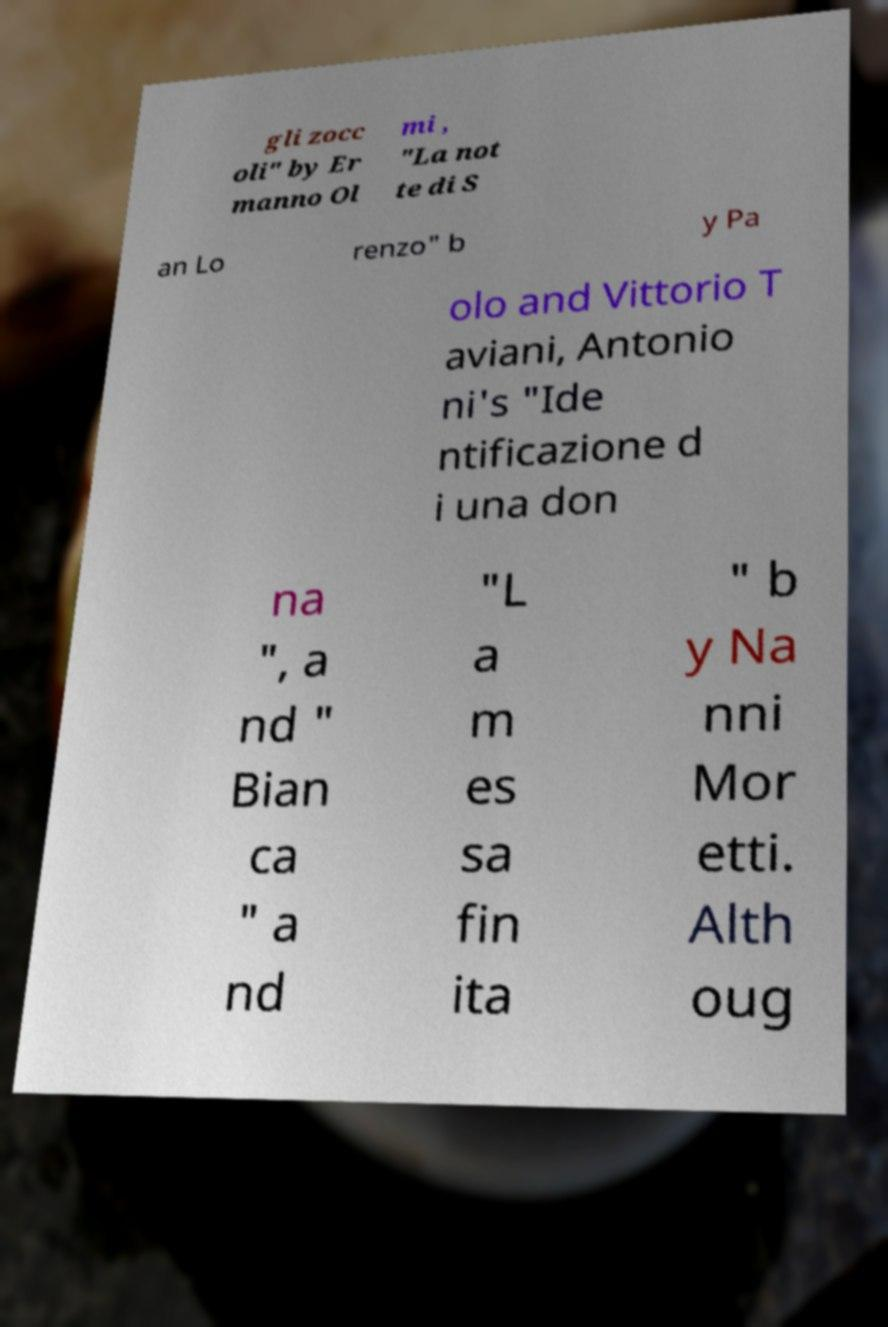What messages or text are displayed in this image? I need them in a readable, typed format. gli zocc oli" by Er manno Ol mi , "La not te di S an Lo renzo" b y Pa olo and Vittorio T aviani, Antonio ni's "Ide ntificazione d i una don na ", a nd " Bian ca " a nd "L a m es sa fin ita " b y Na nni Mor etti. Alth oug 